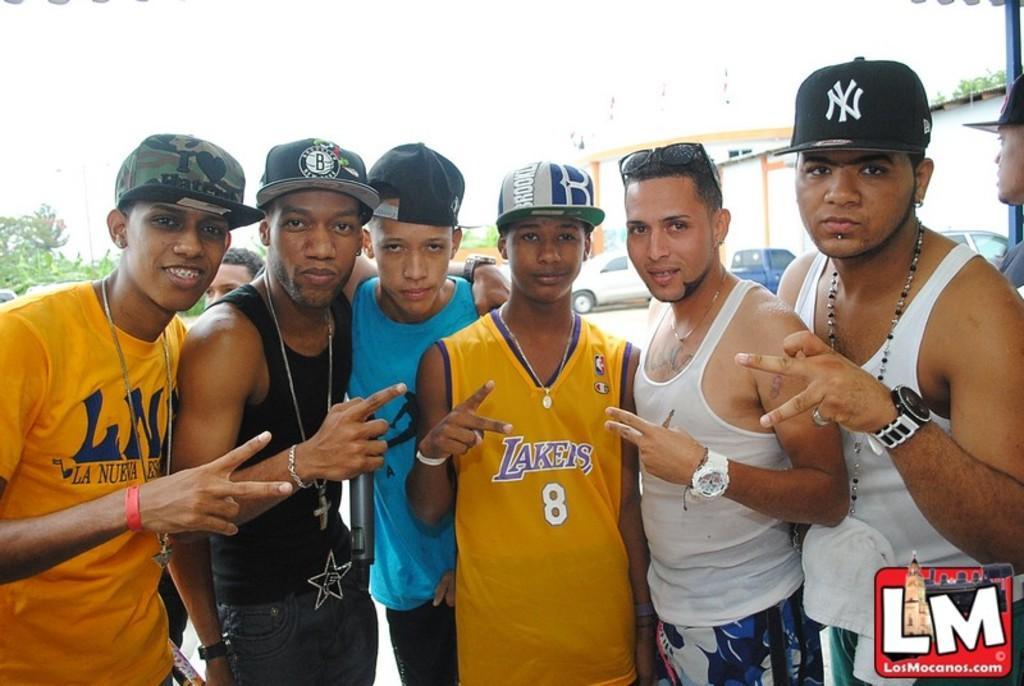Could you give a brief overview of what you see in this image? In this image I can see few persons wearing caps are standing. In the background I can see few trees, few vehicles on the ground, few buildings and the sky. 